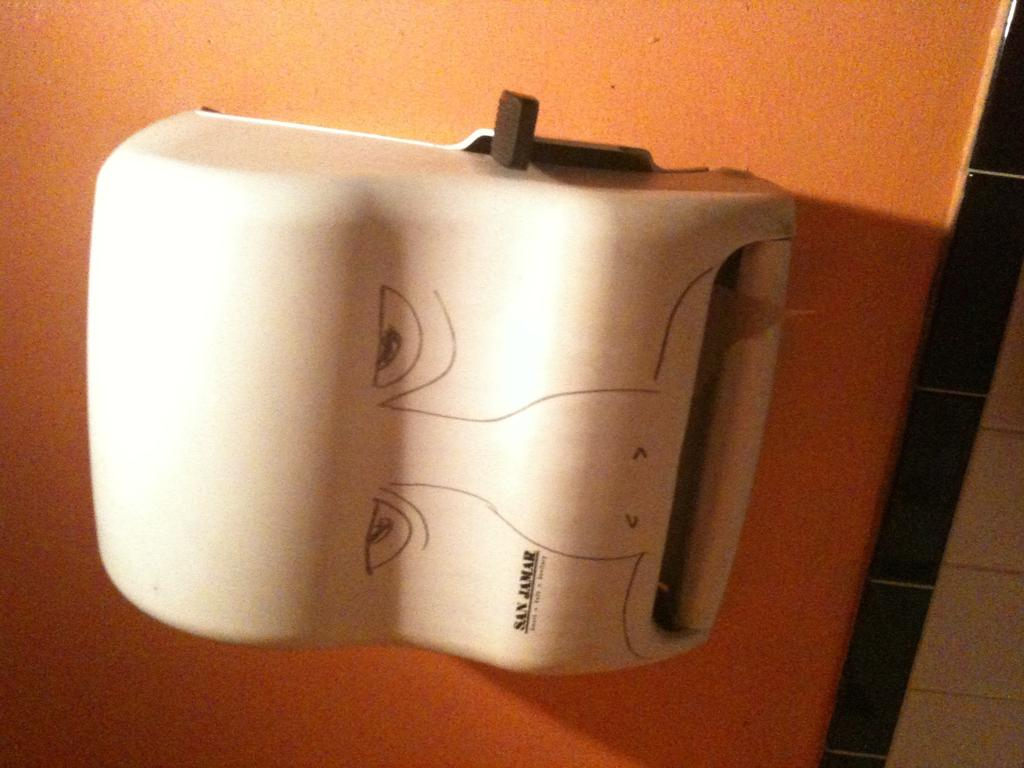What is the color of the box in the image? The box in the image is white. How is the box positioned in the image? The box is attached to a wall. What is the color of the wall to which the box is attached? The wall is in orange color. How many minutes does it take for the box to move from one side of the wall to the other in the image? The box does not move in the image, so it is not possible to determine how many minutes it would take for it to move from one side of the wall to the other. 